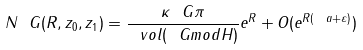Convert formula to latex. <formula><loc_0><loc_0><loc_500><loc_500>N _ { \ } G ( R , z _ { 0 } , z _ { 1 } ) = \frac { \kappa _ { \ } G \pi } { \ v o l ( \ G m o d H ) } e ^ { R } + O ( e ^ { R ( \ a + \varepsilon ) } )</formula> 